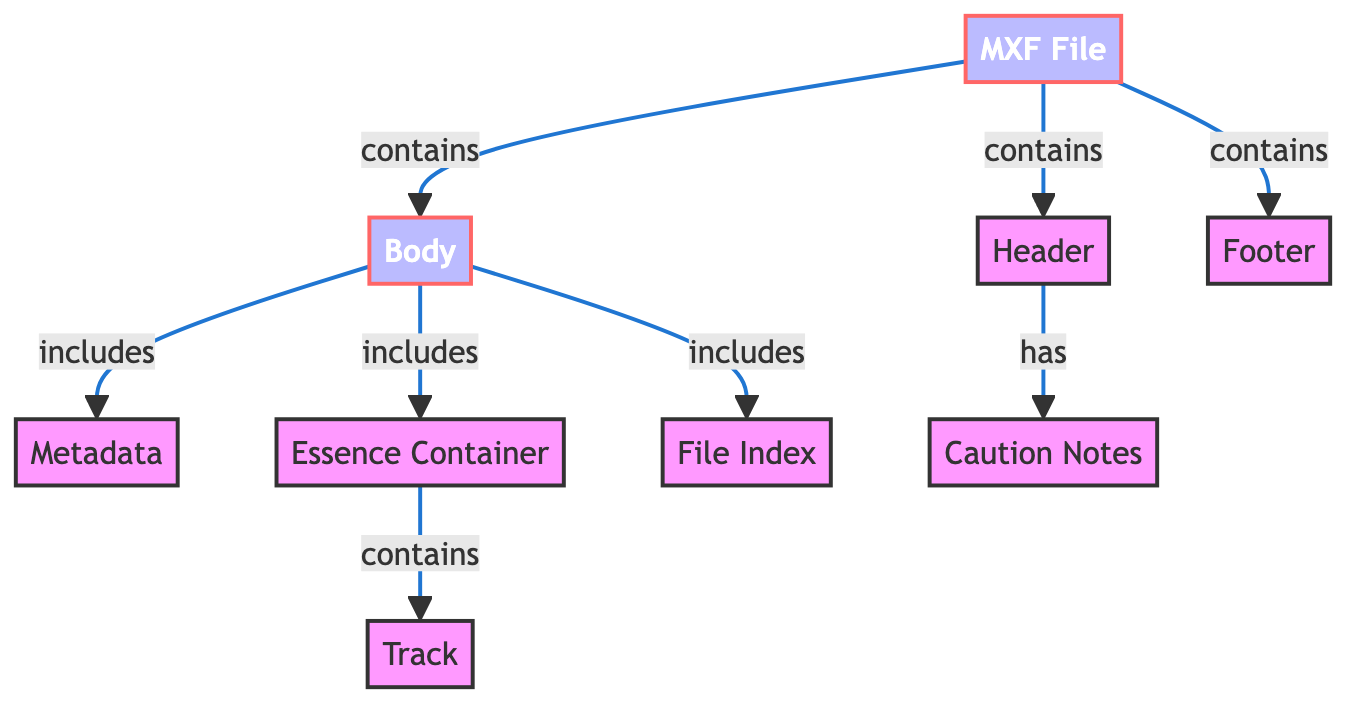What is the main component called in this diagram? The main component in the diagram is represented by the node labeled "MXF File," which serves as the root from which other elements originate.
Answer: MXF File How many nodes are there in total? By counting all the unique elements depicted in the diagram, there are nine nodes labeled: MXF File, Header, Body, Footer, Metadata, Essence Container, File Index, Track, and Caution Notes.
Answer: 9 What node does the Essence Container lead to? The Essence Container node connects to the Track node, indicating that it contains information related to tracks within the MXF file structure.
Answer: Track Which component contains caution notes? The Header node is connected to Caution Notes, indicating that it includes or holds the cautionary information pertinent to the file.
Answer: Header How many edges connect to the Body node? The Body node has three outgoing edges that connect to Metadata, Essence Container, and File Index, indicating it organizes other components within it.
Answer: 3 What component is present in the Footer? The diagram does not specify any additional components or direct relationships emerging from the Footer node, thereby indicating it does not contain further descriptions or items.
Answer: None Which part of the MXF File is organized in a hierarchical manner? The Body node includes multiple elements within it, such as Metadata, Essence Container, and File Index, which showcases a hierarchical arrangement of components related to the file's body structure.
Answer: Body What does the MXF File directly contain? The MXF File node has direct connections to Header, Body, and Footer, illustrating that these sections are fundamental parts of the MXF file's structure.
Answer: Header, Body, Footer How many components does the Header include? The Header node connects solely to Caution Notes, which indicates it contains only one component related to cautionary information.
Answer: 1 